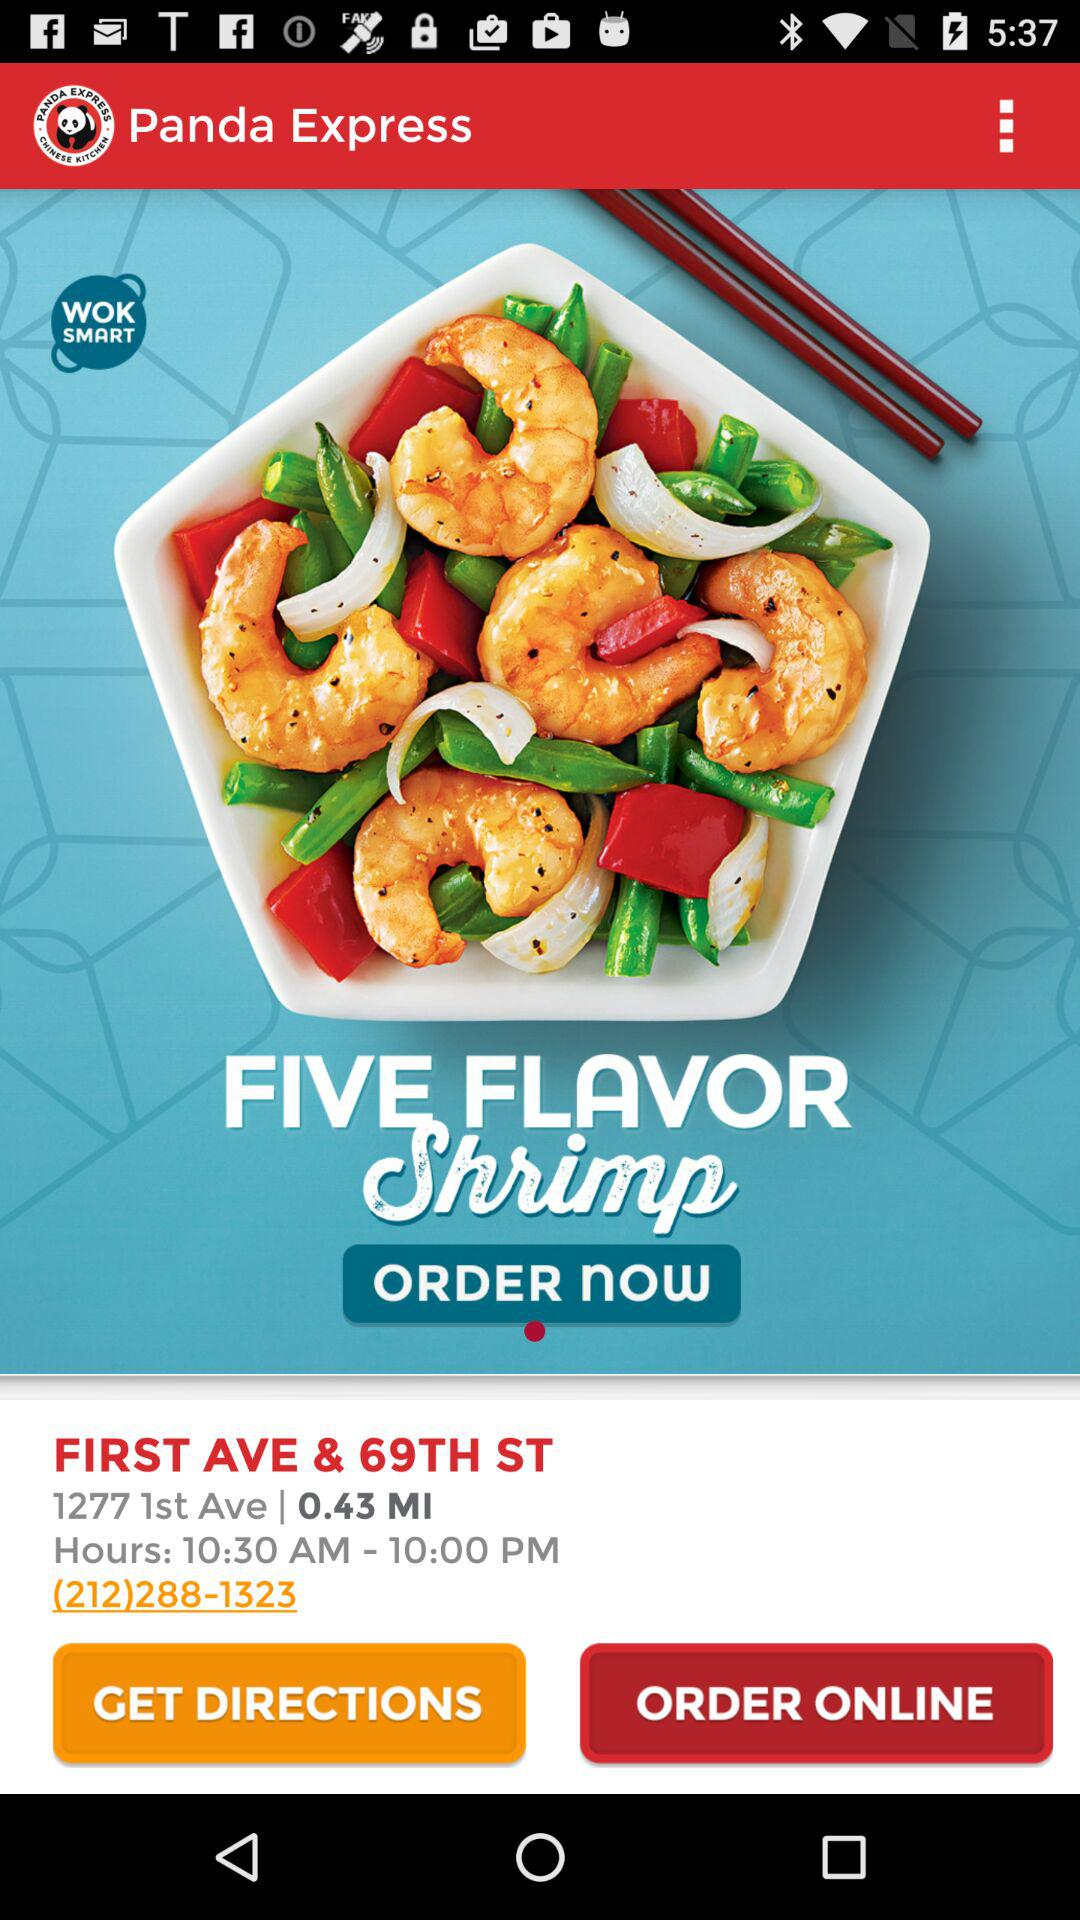How far is the restaurant? The restaurant is 0.43 miles away. 